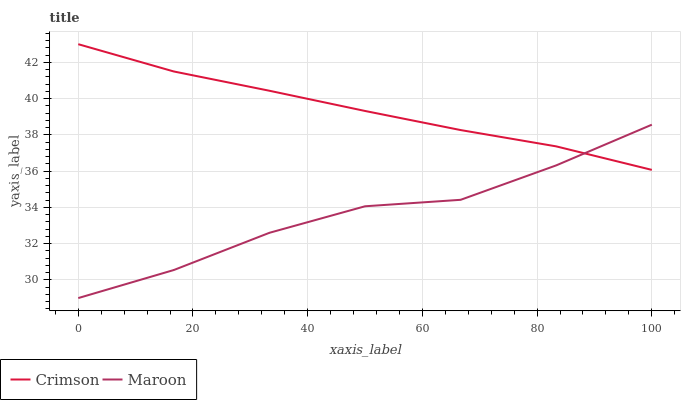Does Maroon have the minimum area under the curve?
Answer yes or no. Yes. Does Crimson have the maximum area under the curve?
Answer yes or no. Yes. Does Maroon have the maximum area under the curve?
Answer yes or no. No. Is Crimson the smoothest?
Answer yes or no. Yes. Is Maroon the roughest?
Answer yes or no. Yes. Is Maroon the smoothest?
Answer yes or no. No. Does Maroon have the lowest value?
Answer yes or no. Yes. Does Crimson have the highest value?
Answer yes or no. Yes. Does Maroon have the highest value?
Answer yes or no. No. Does Maroon intersect Crimson?
Answer yes or no. Yes. Is Maroon less than Crimson?
Answer yes or no. No. Is Maroon greater than Crimson?
Answer yes or no. No. 